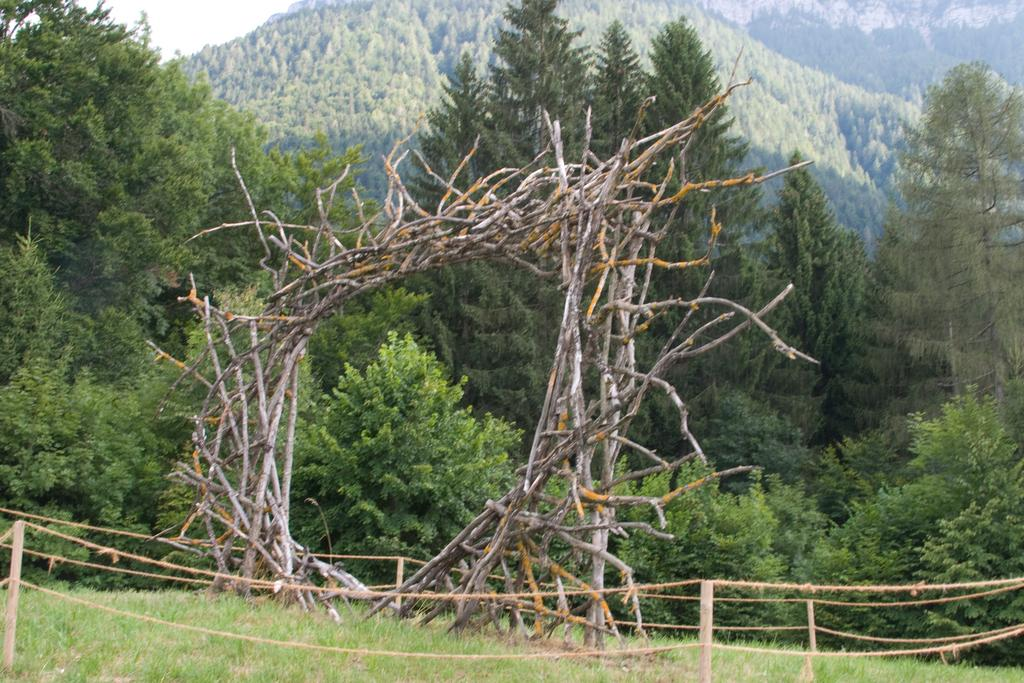What type of vegetation is in the center of the image? There is grass in the center of the image. What structure can be seen in the image that has branches? There is an arch with branches in the image. What type of fence is visible in the image? There is a fence with poles and ropes in the image. What can be seen in the background of the image? The sky and trees are visible in the background of the image. What decision does the boot make in the image? There is no boot present in the image, so no decision can be made by it. How does the start of the race look like in the image? There is no race or start depicted in the image. 